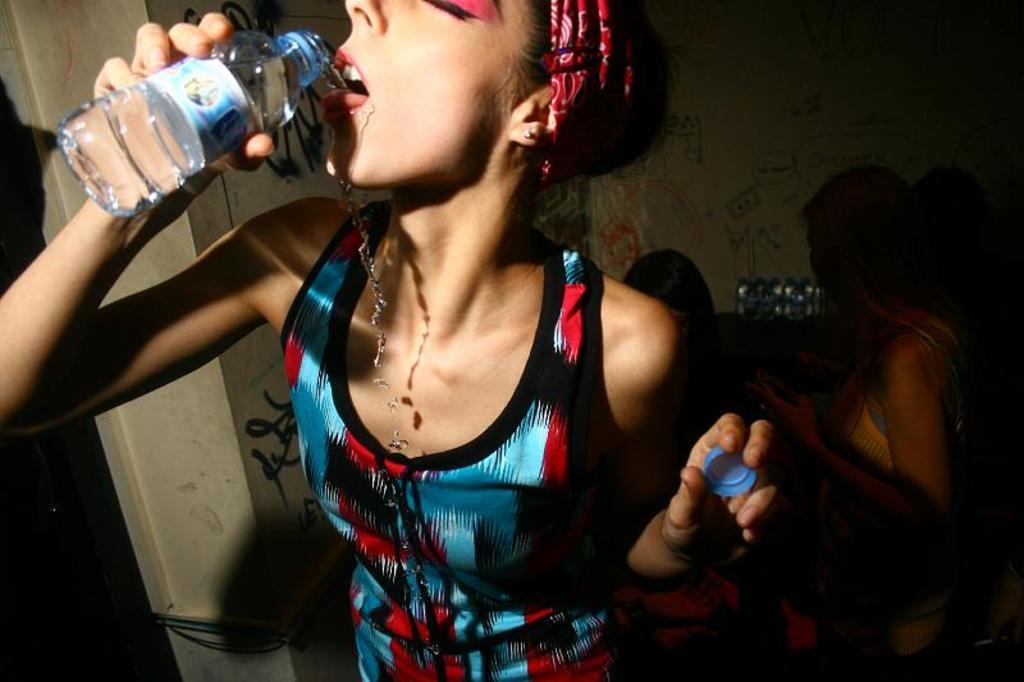Who is the main subject in the image? There is a girl in the image. What is the girl wearing? The girl is wearing a blue and red dress. Where is the girl positioned in the image? The girl is standing in the front. What is the girl doing in the image? The girl is drinking water from a bottle. Who else is present in the image? There is a woman in the image. What can be seen in the background of the image? There is a white wall in the background. How many sons does the girl have in the image? There is no mention of sons in the image; it only features a girl and a woman. 